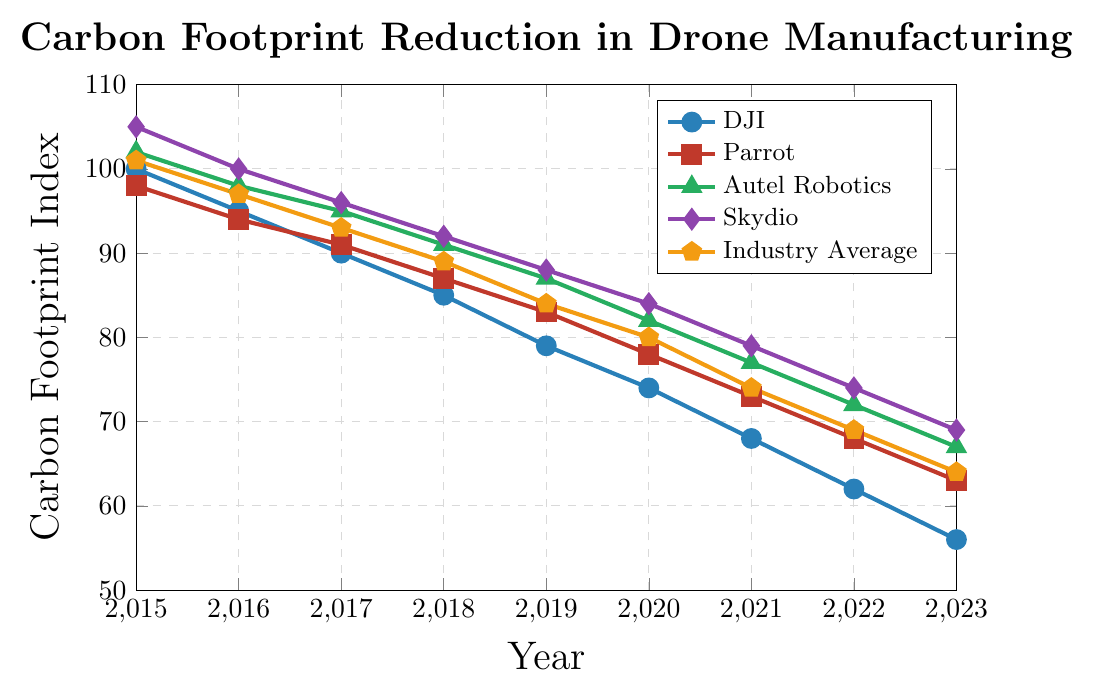What's the trend in the carbon footprint index for DJI from 2015 to 2023? The line chart shows that the carbon footprint index for DJI has decreased consistently from 100 in 2015 to 56 in 2023.
Answer: Downward trend Between which years did Parrot show the highest reduction in carbon footprint index? The chart indicates that the steepest drop for Parrot is between 2017 and 2018, where it reduced from 91 to 87.
Answer: 2017 to 2018 Which company had the highest carbon footprint index in 2020? According to the chart, Skydio had the highest carbon footprint index in 2020, with a value of 84.
Answer: Skydio How does the industry average carbon footprint index in 2023 compare to DJI's value in the same year? The chart shows that the industry average is 64 in 2023, while DJI's value is 56, indicating the industry average is higher than DJI's value.
Answer: Industry average is higher What is the average carbon footprint index of all companies in 2017? Adding the values for all companies in 2017: (90 + 91 + 95 + 96) / 4 = 93. For the total average, include the industry average (93). This gives (90 + 91 + 95 + 96 + 93) / 5 = 93.
Answer: 93 Which company exhibited the most significant improvement from 2015 to 2023? By subtracting the 2023 value from the 2015 value for each company: DJI (100-56), Parrot (98-63), Autel Robotics (102-67), Skydio (105-69). DJI shows the largest reduction from 100 to 56, a difference of 44.
Answer: DJI What color line represents the changes in Autel Robotics' carbon footprint index? The color line representing Autel Robotics in the chart is green.
Answer: Green In what year did Skydio’s carbon footprint index fall below 90 for the first time? According to the chart, Skydio's carbon footprint index first falls below 90 in the year 2019.
Answer: 2019 If the trend continues, what might be the expected carbon footprint index for the industry average in 2024? Observing the consistent annual reduction, we notice the industry average dropped by approximately 4-5 points each year from 2015-2023. Estimating for 2024, we subtract around 4-5 points from 64 (2023 value), predicting it could be around 59-60 in 2024.
Answer: 59-60 